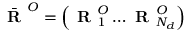Convert formula to latex. <formula><loc_0><loc_0><loc_500><loc_500>\bar { R } ^ { O } = \left ( R _ { 1 } ^ { O } \dots R _ { N _ { d } } ^ { O } \right )</formula> 